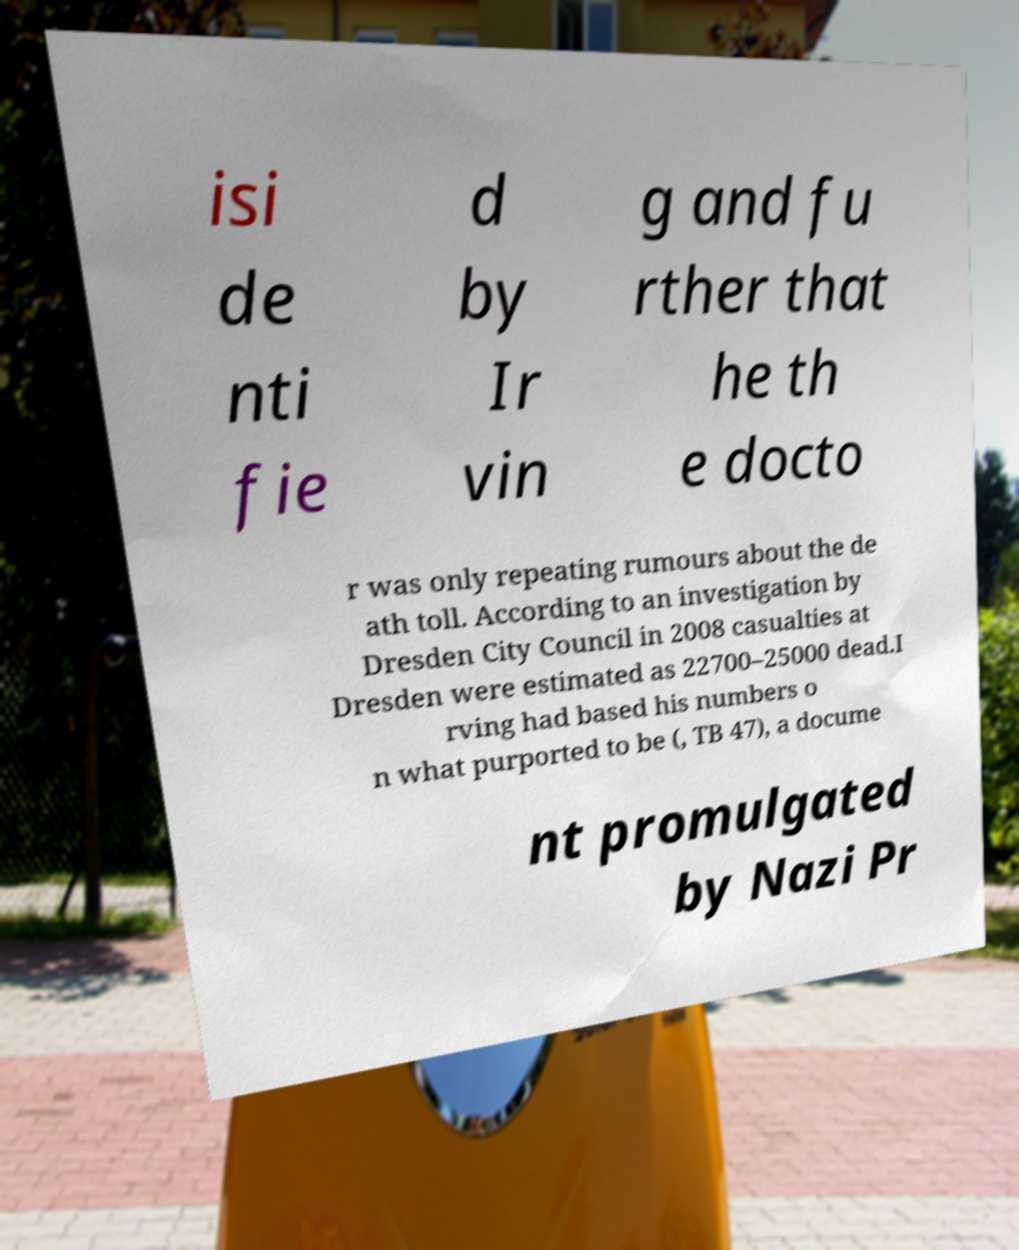Can you read and provide the text displayed in the image?This photo seems to have some interesting text. Can you extract and type it out for me? isi de nti fie d by Ir vin g and fu rther that he th e docto r was only repeating rumours about the de ath toll. According to an investigation by Dresden City Council in 2008 casualties at Dresden were estimated as 22700–25000 dead.I rving had based his numbers o n what purported to be (, TB 47), a docume nt promulgated by Nazi Pr 